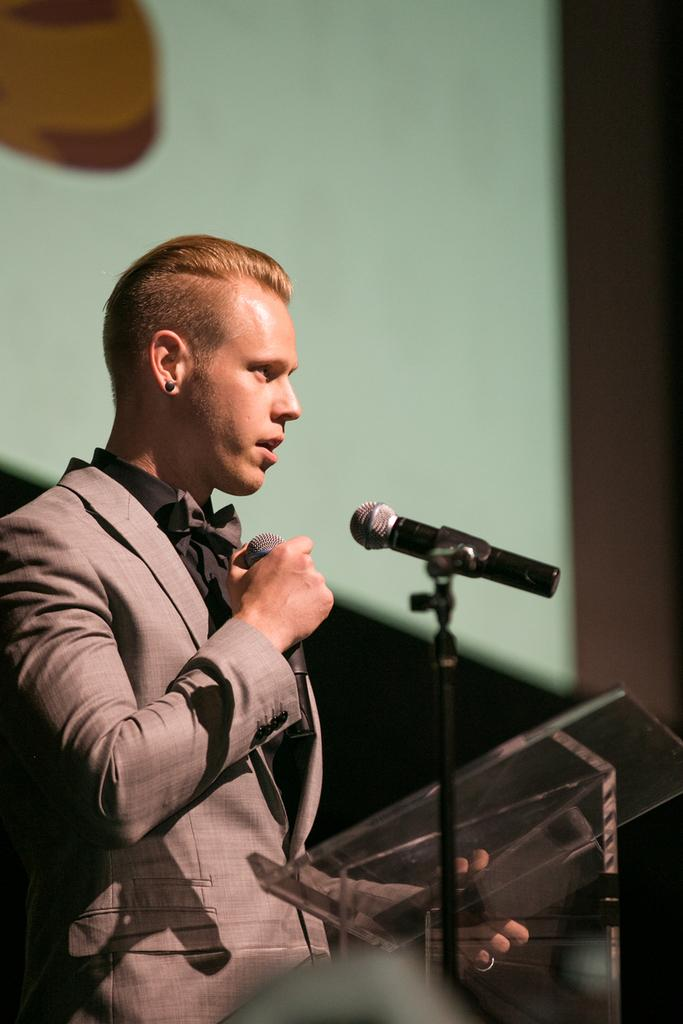Who is the main subject in the image? There is a man in the image. What is the man holding in the image? The man is holding a mic. What is the man standing in front of in the image? The man is standing in front of a podium. What is the man wearing in the image? The man is wearing a suit. What type of humor is the man using while playing the guitar in the image? There is no guitar present in the image, and the man is not using any humor. 